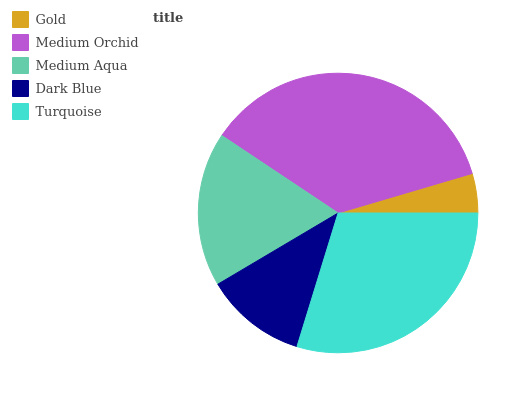Is Gold the minimum?
Answer yes or no. Yes. Is Medium Orchid the maximum?
Answer yes or no. Yes. Is Medium Aqua the minimum?
Answer yes or no. No. Is Medium Aqua the maximum?
Answer yes or no. No. Is Medium Orchid greater than Medium Aqua?
Answer yes or no. Yes. Is Medium Aqua less than Medium Orchid?
Answer yes or no. Yes. Is Medium Aqua greater than Medium Orchid?
Answer yes or no. No. Is Medium Orchid less than Medium Aqua?
Answer yes or no. No. Is Medium Aqua the high median?
Answer yes or no. Yes. Is Medium Aqua the low median?
Answer yes or no. Yes. Is Turquoise the high median?
Answer yes or no. No. Is Dark Blue the low median?
Answer yes or no. No. 